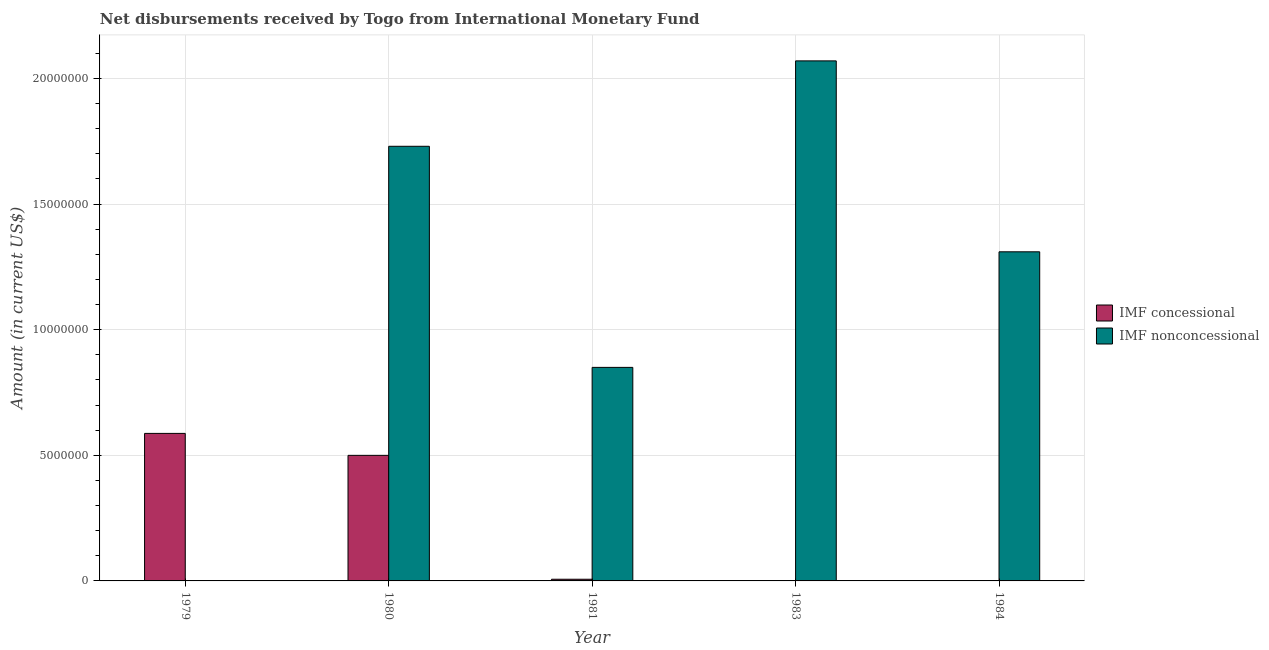How many different coloured bars are there?
Your response must be concise. 2. How many bars are there on the 1st tick from the left?
Keep it short and to the point. 1. What is the label of the 5th group of bars from the left?
Provide a short and direct response. 1984. In how many cases, is the number of bars for a given year not equal to the number of legend labels?
Your response must be concise. 3. What is the net concessional disbursements from imf in 1980?
Give a very brief answer. 5.00e+06. Across all years, what is the maximum net concessional disbursements from imf?
Your answer should be compact. 5.87e+06. Across all years, what is the minimum net non concessional disbursements from imf?
Your answer should be compact. 0. In which year was the net concessional disbursements from imf maximum?
Provide a succinct answer. 1979. What is the total net concessional disbursements from imf in the graph?
Provide a succinct answer. 1.09e+07. What is the difference between the net concessional disbursements from imf in 1979 and that in 1980?
Provide a short and direct response. 8.74e+05. What is the difference between the net non concessional disbursements from imf in 1980 and the net concessional disbursements from imf in 1981?
Ensure brevity in your answer.  8.80e+06. What is the average net concessional disbursements from imf per year?
Your response must be concise. 2.19e+06. In the year 1984, what is the difference between the net non concessional disbursements from imf and net concessional disbursements from imf?
Your response must be concise. 0. What is the ratio of the net non concessional disbursements from imf in 1981 to that in 1984?
Your answer should be very brief. 0.65. Is the net non concessional disbursements from imf in 1980 less than that in 1981?
Provide a succinct answer. No. Is the difference between the net non concessional disbursements from imf in 1980 and 1984 greater than the difference between the net concessional disbursements from imf in 1980 and 1984?
Your answer should be very brief. No. What is the difference between the highest and the second highest net concessional disbursements from imf?
Your answer should be compact. 8.74e+05. What is the difference between the highest and the lowest net non concessional disbursements from imf?
Offer a very short reply. 2.07e+07. Is the sum of the net non concessional disbursements from imf in 1980 and 1981 greater than the maximum net concessional disbursements from imf across all years?
Ensure brevity in your answer.  Yes. Are all the bars in the graph horizontal?
Provide a succinct answer. No. What is the difference between two consecutive major ticks on the Y-axis?
Your answer should be compact. 5.00e+06. Does the graph contain any zero values?
Offer a very short reply. Yes. Does the graph contain grids?
Provide a short and direct response. Yes. Where does the legend appear in the graph?
Offer a very short reply. Center right. How are the legend labels stacked?
Your answer should be very brief. Vertical. What is the title of the graph?
Make the answer very short. Net disbursements received by Togo from International Monetary Fund. Does "Foreign liabilities" appear as one of the legend labels in the graph?
Ensure brevity in your answer.  No. What is the label or title of the Y-axis?
Offer a very short reply. Amount (in current US$). What is the Amount (in current US$) of IMF concessional in 1979?
Give a very brief answer. 5.87e+06. What is the Amount (in current US$) of IMF nonconcessional in 1979?
Your answer should be compact. 0. What is the Amount (in current US$) in IMF concessional in 1980?
Your answer should be very brief. 5.00e+06. What is the Amount (in current US$) of IMF nonconcessional in 1980?
Offer a very short reply. 1.73e+07. What is the Amount (in current US$) in IMF concessional in 1981?
Make the answer very short. 6.70e+04. What is the Amount (in current US$) in IMF nonconcessional in 1981?
Your response must be concise. 8.50e+06. What is the Amount (in current US$) of IMF nonconcessional in 1983?
Your response must be concise. 2.07e+07. What is the Amount (in current US$) in IMF concessional in 1984?
Offer a very short reply. 0. What is the Amount (in current US$) in IMF nonconcessional in 1984?
Offer a very short reply. 1.31e+07. Across all years, what is the maximum Amount (in current US$) of IMF concessional?
Your answer should be compact. 5.87e+06. Across all years, what is the maximum Amount (in current US$) in IMF nonconcessional?
Your response must be concise. 2.07e+07. Across all years, what is the minimum Amount (in current US$) in IMF nonconcessional?
Provide a succinct answer. 0. What is the total Amount (in current US$) of IMF concessional in the graph?
Ensure brevity in your answer.  1.09e+07. What is the total Amount (in current US$) of IMF nonconcessional in the graph?
Ensure brevity in your answer.  5.96e+07. What is the difference between the Amount (in current US$) of IMF concessional in 1979 and that in 1980?
Provide a succinct answer. 8.74e+05. What is the difference between the Amount (in current US$) in IMF concessional in 1979 and that in 1981?
Give a very brief answer. 5.80e+06. What is the difference between the Amount (in current US$) of IMF concessional in 1980 and that in 1981?
Offer a very short reply. 4.93e+06. What is the difference between the Amount (in current US$) of IMF nonconcessional in 1980 and that in 1981?
Ensure brevity in your answer.  8.80e+06. What is the difference between the Amount (in current US$) of IMF nonconcessional in 1980 and that in 1983?
Provide a succinct answer. -3.40e+06. What is the difference between the Amount (in current US$) in IMF nonconcessional in 1980 and that in 1984?
Provide a short and direct response. 4.20e+06. What is the difference between the Amount (in current US$) of IMF nonconcessional in 1981 and that in 1983?
Your answer should be compact. -1.22e+07. What is the difference between the Amount (in current US$) in IMF nonconcessional in 1981 and that in 1984?
Your response must be concise. -4.60e+06. What is the difference between the Amount (in current US$) in IMF nonconcessional in 1983 and that in 1984?
Ensure brevity in your answer.  7.60e+06. What is the difference between the Amount (in current US$) of IMF concessional in 1979 and the Amount (in current US$) of IMF nonconcessional in 1980?
Provide a short and direct response. -1.14e+07. What is the difference between the Amount (in current US$) in IMF concessional in 1979 and the Amount (in current US$) in IMF nonconcessional in 1981?
Give a very brief answer. -2.63e+06. What is the difference between the Amount (in current US$) in IMF concessional in 1979 and the Amount (in current US$) in IMF nonconcessional in 1983?
Provide a succinct answer. -1.48e+07. What is the difference between the Amount (in current US$) of IMF concessional in 1979 and the Amount (in current US$) of IMF nonconcessional in 1984?
Make the answer very short. -7.23e+06. What is the difference between the Amount (in current US$) of IMF concessional in 1980 and the Amount (in current US$) of IMF nonconcessional in 1981?
Offer a terse response. -3.50e+06. What is the difference between the Amount (in current US$) in IMF concessional in 1980 and the Amount (in current US$) in IMF nonconcessional in 1983?
Provide a succinct answer. -1.57e+07. What is the difference between the Amount (in current US$) in IMF concessional in 1980 and the Amount (in current US$) in IMF nonconcessional in 1984?
Your answer should be very brief. -8.10e+06. What is the difference between the Amount (in current US$) of IMF concessional in 1981 and the Amount (in current US$) of IMF nonconcessional in 1983?
Your answer should be compact. -2.06e+07. What is the difference between the Amount (in current US$) in IMF concessional in 1981 and the Amount (in current US$) in IMF nonconcessional in 1984?
Ensure brevity in your answer.  -1.30e+07. What is the average Amount (in current US$) of IMF concessional per year?
Your answer should be very brief. 2.19e+06. What is the average Amount (in current US$) in IMF nonconcessional per year?
Your answer should be very brief. 1.19e+07. In the year 1980, what is the difference between the Amount (in current US$) of IMF concessional and Amount (in current US$) of IMF nonconcessional?
Your answer should be compact. -1.23e+07. In the year 1981, what is the difference between the Amount (in current US$) of IMF concessional and Amount (in current US$) of IMF nonconcessional?
Ensure brevity in your answer.  -8.43e+06. What is the ratio of the Amount (in current US$) of IMF concessional in 1979 to that in 1980?
Provide a short and direct response. 1.17. What is the ratio of the Amount (in current US$) in IMF concessional in 1979 to that in 1981?
Keep it short and to the point. 87.64. What is the ratio of the Amount (in current US$) in IMF concessional in 1980 to that in 1981?
Offer a very short reply. 74.6. What is the ratio of the Amount (in current US$) of IMF nonconcessional in 1980 to that in 1981?
Give a very brief answer. 2.04. What is the ratio of the Amount (in current US$) of IMF nonconcessional in 1980 to that in 1983?
Your answer should be compact. 0.84. What is the ratio of the Amount (in current US$) in IMF nonconcessional in 1980 to that in 1984?
Give a very brief answer. 1.32. What is the ratio of the Amount (in current US$) in IMF nonconcessional in 1981 to that in 1983?
Provide a short and direct response. 0.41. What is the ratio of the Amount (in current US$) of IMF nonconcessional in 1981 to that in 1984?
Offer a very short reply. 0.65. What is the ratio of the Amount (in current US$) in IMF nonconcessional in 1983 to that in 1984?
Make the answer very short. 1.58. What is the difference between the highest and the second highest Amount (in current US$) of IMF concessional?
Your response must be concise. 8.74e+05. What is the difference between the highest and the second highest Amount (in current US$) of IMF nonconcessional?
Offer a terse response. 3.40e+06. What is the difference between the highest and the lowest Amount (in current US$) of IMF concessional?
Offer a terse response. 5.87e+06. What is the difference between the highest and the lowest Amount (in current US$) of IMF nonconcessional?
Provide a succinct answer. 2.07e+07. 